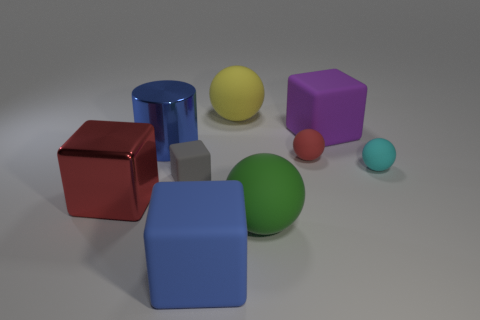Subtract 1 cubes. How many cubes are left? 3 Subtract all red blocks. How many blocks are left? 3 Subtract all red spheres. How many spheres are left? 3 Subtract all spheres. How many objects are left? 5 Subtract all gray balls. Subtract all brown cylinders. How many balls are left? 4 Add 1 big cyan metallic cubes. How many big cyan metallic cubes exist? 1 Subtract 1 red cubes. How many objects are left? 8 Subtract all brown rubber objects. Subtract all cyan spheres. How many objects are left? 8 Add 8 purple blocks. How many purple blocks are left? 9 